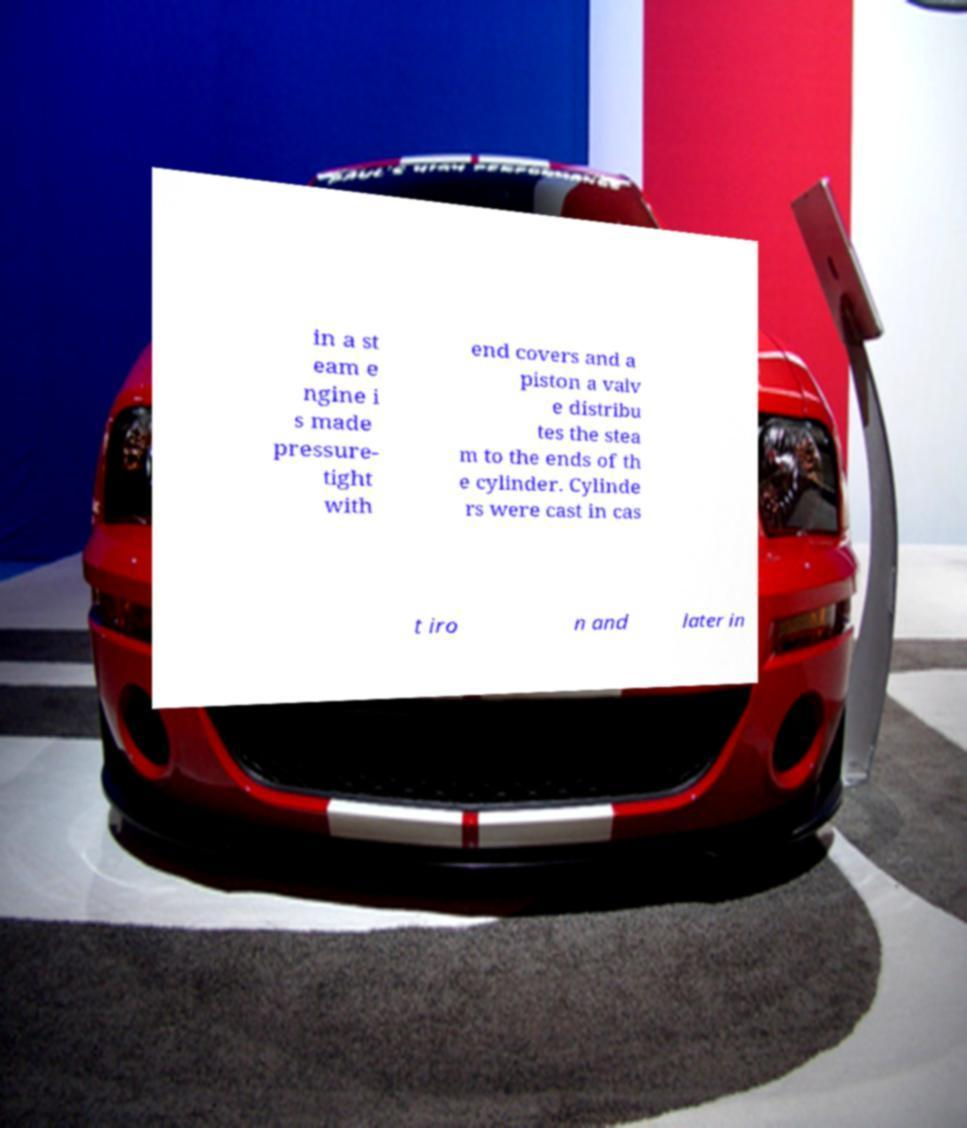Could you extract and type out the text from this image? in a st eam e ngine i s made pressure- tight with end covers and a piston a valv e distribu tes the stea m to the ends of th e cylinder. Cylinde rs were cast in cas t iro n and later in 